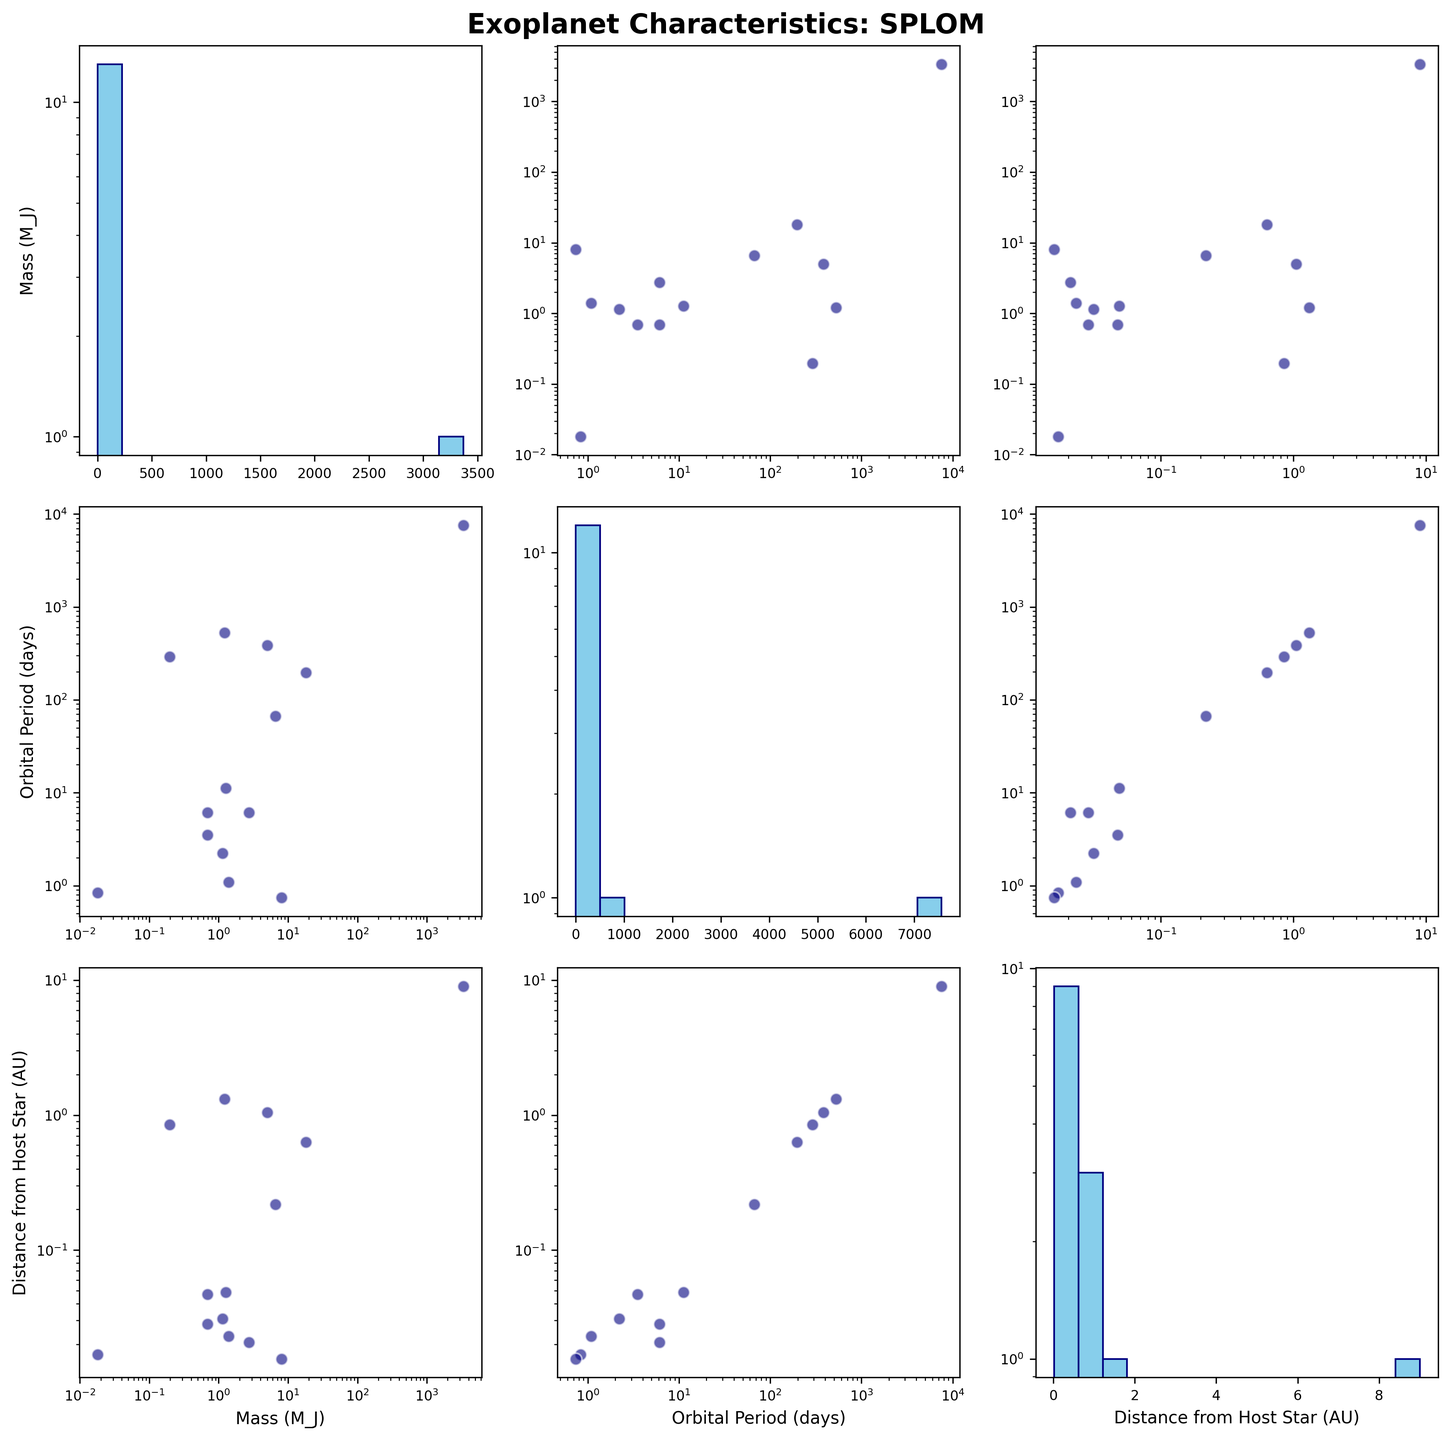What's the title of the figure? The title is displayed at the top of the figure in bold text.
Answer: Exoplanet Characteristics: SPLOM Which variable is represented on the x-axis of the middle column? The x-axis of the middle column represents "Orbital Period (days)" as seen from the axis label below that column.
Answer: Orbital Period (days) How is the distribution of "Mass (M_J)" represented when compared to itself? The distribution of "Mass (M_J)" when compared to itself is represented by a histogram in the top-left cell of the matrix.
Answer: Histogram Which variables show a positive correlation, if any? A positive correlation is seen when both variables increase together. From the scatter plots, "Mass (M_J)" and "Distance from Host Star (AU)" show a positive correlation.
Answer: Mass (M_J) and Distance from Host Star (AU) What's the minimum "Distance from Host Star (AU)" and which exoplanet does it belong to? The minimum "Distance from Host Star (AU)" is identified by finding the smallest value on the x or y axis in the scatter plots or the histogram. It is 0.0156 AU belonging to 55 Cancri e.
Answer: 0.0156 AU, 55 Cancri e How does the range of "Orbital Period (days)" in the sample? The range is observed from the minimum to the maximum value along the x or y axis in the histograms or scatter plots. It ranges from approximately 0.74 days to 7565 days.
Answer: 0.74 days to 7565 days Is there a distinct pattern or clustering in the scatter plot of "Orbital Period (days)" vs "Distance from Host Star (AU)"? A distinct pattern is seen when points form a noticeable shape or cluster together. The scatter plot for these variables shows a general trend where longer orbital periods are associated with greater distances from the host star.
Answer: Longer orbital periods at greater distances Which exoplanet has the highest mass and where is it positioned in the scatter plots? The exoplanet with the highest mass is identified from the histogram and scatter plots. Beta Pictoris b has the highest mass, and it is positioned at the far right in scatter plots involving "Mass (M_J)".
Answer: Beta Pictoris b What is the common relationship trend between "Mass (M_J)" and "Orbital Period (days)"? The common trend is observed from the scatter plot between these variables. There appears to be no clear monotonic relationship, indicating mass and orbital period do not have a straightforward linear correlation.
Answer: No clear monotonic relationship 